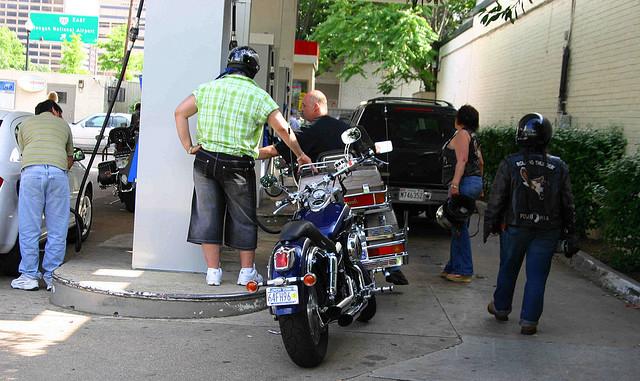Where are the people?
Concise answer only. Gas station. Where are these people at?
Concise answer only. Gas station. What color is the women's vest?
Write a very short answer. Black. Is the man parking his bike?
Give a very brief answer. No. How many motorcycles are there?
Be succinct. 3. 